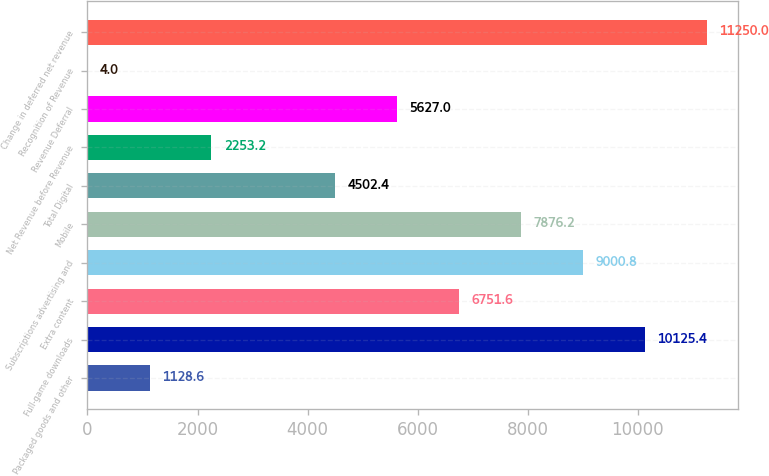Convert chart to OTSL. <chart><loc_0><loc_0><loc_500><loc_500><bar_chart><fcel>Packaged goods and other<fcel>Full-game downloads<fcel>Extra content<fcel>Subscriptions advertising and<fcel>Mobile<fcel>Total Digital<fcel>Net Revenue before Revenue<fcel>Revenue Deferral<fcel>Recognition of Revenue<fcel>Change in deferred net revenue<nl><fcel>1128.6<fcel>10125.4<fcel>6751.6<fcel>9000.8<fcel>7876.2<fcel>4502.4<fcel>2253.2<fcel>5627<fcel>4<fcel>11250<nl></chart> 